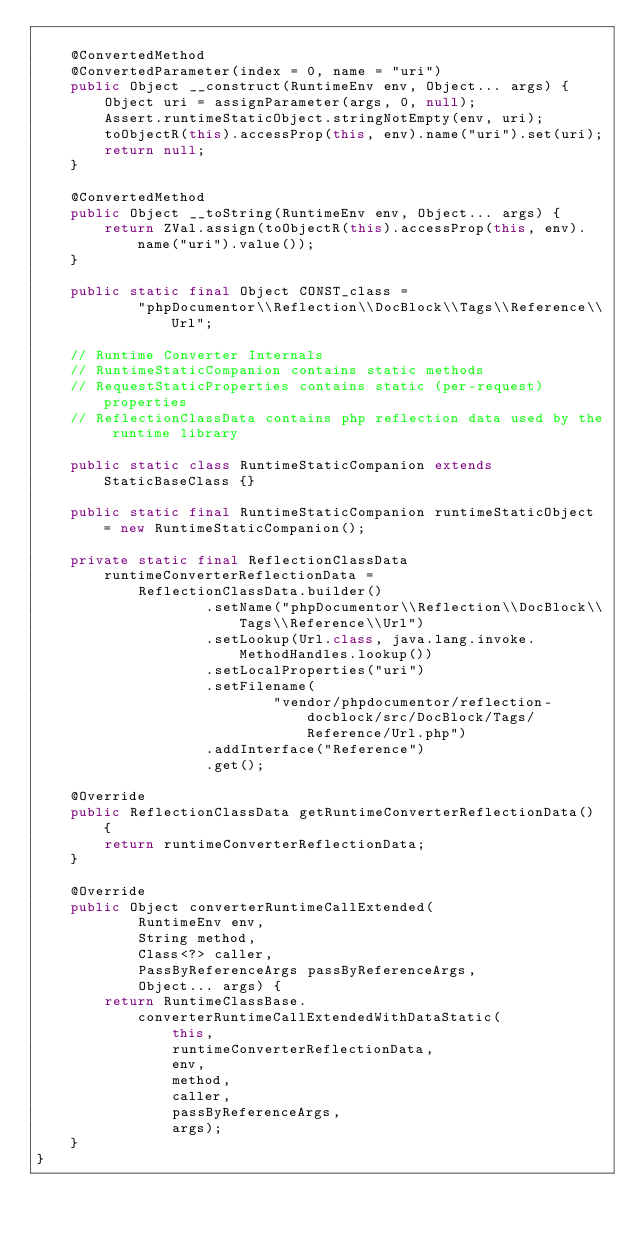Convert code to text. <code><loc_0><loc_0><loc_500><loc_500><_Java_>
    @ConvertedMethod
    @ConvertedParameter(index = 0, name = "uri")
    public Object __construct(RuntimeEnv env, Object... args) {
        Object uri = assignParameter(args, 0, null);
        Assert.runtimeStaticObject.stringNotEmpty(env, uri);
        toObjectR(this).accessProp(this, env).name("uri").set(uri);
        return null;
    }

    @ConvertedMethod
    public Object __toString(RuntimeEnv env, Object... args) {
        return ZVal.assign(toObjectR(this).accessProp(this, env).name("uri").value());
    }

    public static final Object CONST_class =
            "phpDocumentor\\Reflection\\DocBlock\\Tags\\Reference\\Url";

    // Runtime Converter Internals
    // RuntimeStaticCompanion contains static methods
    // RequestStaticProperties contains static (per-request) properties
    // ReflectionClassData contains php reflection data used by the runtime library

    public static class RuntimeStaticCompanion extends StaticBaseClass {}

    public static final RuntimeStaticCompanion runtimeStaticObject = new RuntimeStaticCompanion();

    private static final ReflectionClassData runtimeConverterReflectionData =
            ReflectionClassData.builder()
                    .setName("phpDocumentor\\Reflection\\DocBlock\\Tags\\Reference\\Url")
                    .setLookup(Url.class, java.lang.invoke.MethodHandles.lookup())
                    .setLocalProperties("uri")
                    .setFilename(
                            "vendor/phpdocumentor/reflection-docblock/src/DocBlock/Tags/Reference/Url.php")
                    .addInterface("Reference")
                    .get();

    @Override
    public ReflectionClassData getRuntimeConverterReflectionData() {
        return runtimeConverterReflectionData;
    }

    @Override
    public Object converterRuntimeCallExtended(
            RuntimeEnv env,
            String method,
            Class<?> caller,
            PassByReferenceArgs passByReferenceArgs,
            Object... args) {
        return RuntimeClassBase.converterRuntimeCallExtendedWithDataStatic(
                this,
                runtimeConverterReflectionData,
                env,
                method,
                caller,
                passByReferenceArgs,
                args);
    }
}
</code> 